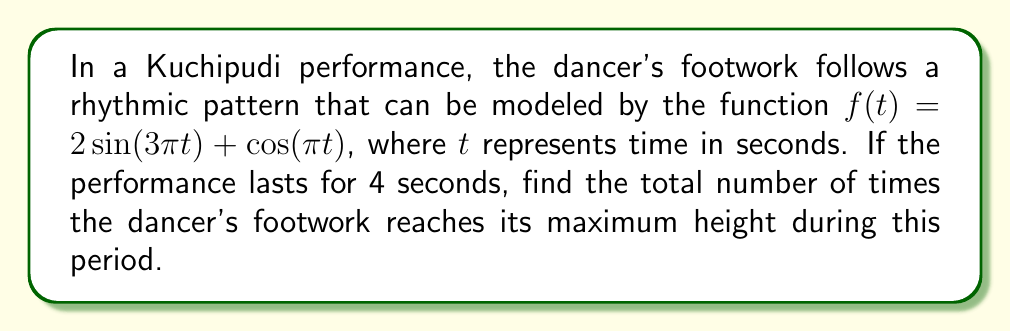Give your solution to this math problem. To solve this problem, we need to follow these steps:

1) First, we need to find the period of the function $f(t) = 2\sin(3\pi t) + \cos(\pi t)$. The period will be the least common multiple (LCM) of the periods of its component functions.

2) For $2\sin(3\pi t)$, the period is $\frac{2\pi}{3\pi} = \frac{2}{3}$ seconds.
   For $\cos(\pi t)$, the period is $\frac{2\pi}{\pi} = 2$ seconds.

3) The LCM of $\frac{2}{3}$ and 2 is 2. So, the period of $f(t)$ is 2 seconds.

4) The function will reach its maximum height once in each period. Since the performance lasts for 4 seconds, we need to calculate how many complete periods occur in 4 seconds.

5) Number of periods = Total time / Period of function
                     = 4 / 2 = 2

Therefore, the dancer's footwork will reach its maximum height twice during the 4-second performance.
Answer: 2 times 